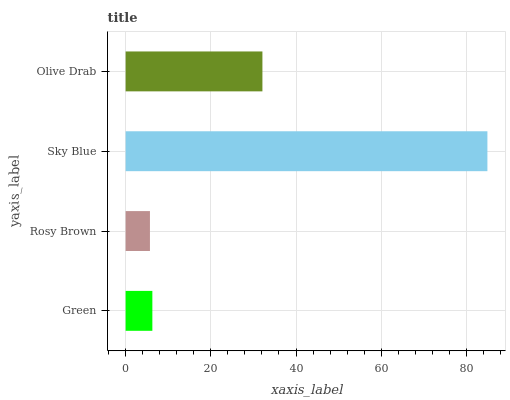Is Rosy Brown the minimum?
Answer yes or no. Yes. Is Sky Blue the maximum?
Answer yes or no. Yes. Is Sky Blue the minimum?
Answer yes or no. No. Is Rosy Brown the maximum?
Answer yes or no. No. Is Sky Blue greater than Rosy Brown?
Answer yes or no. Yes. Is Rosy Brown less than Sky Blue?
Answer yes or no. Yes. Is Rosy Brown greater than Sky Blue?
Answer yes or no. No. Is Sky Blue less than Rosy Brown?
Answer yes or no. No. Is Olive Drab the high median?
Answer yes or no. Yes. Is Green the low median?
Answer yes or no. Yes. Is Sky Blue the high median?
Answer yes or no. No. Is Sky Blue the low median?
Answer yes or no. No. 